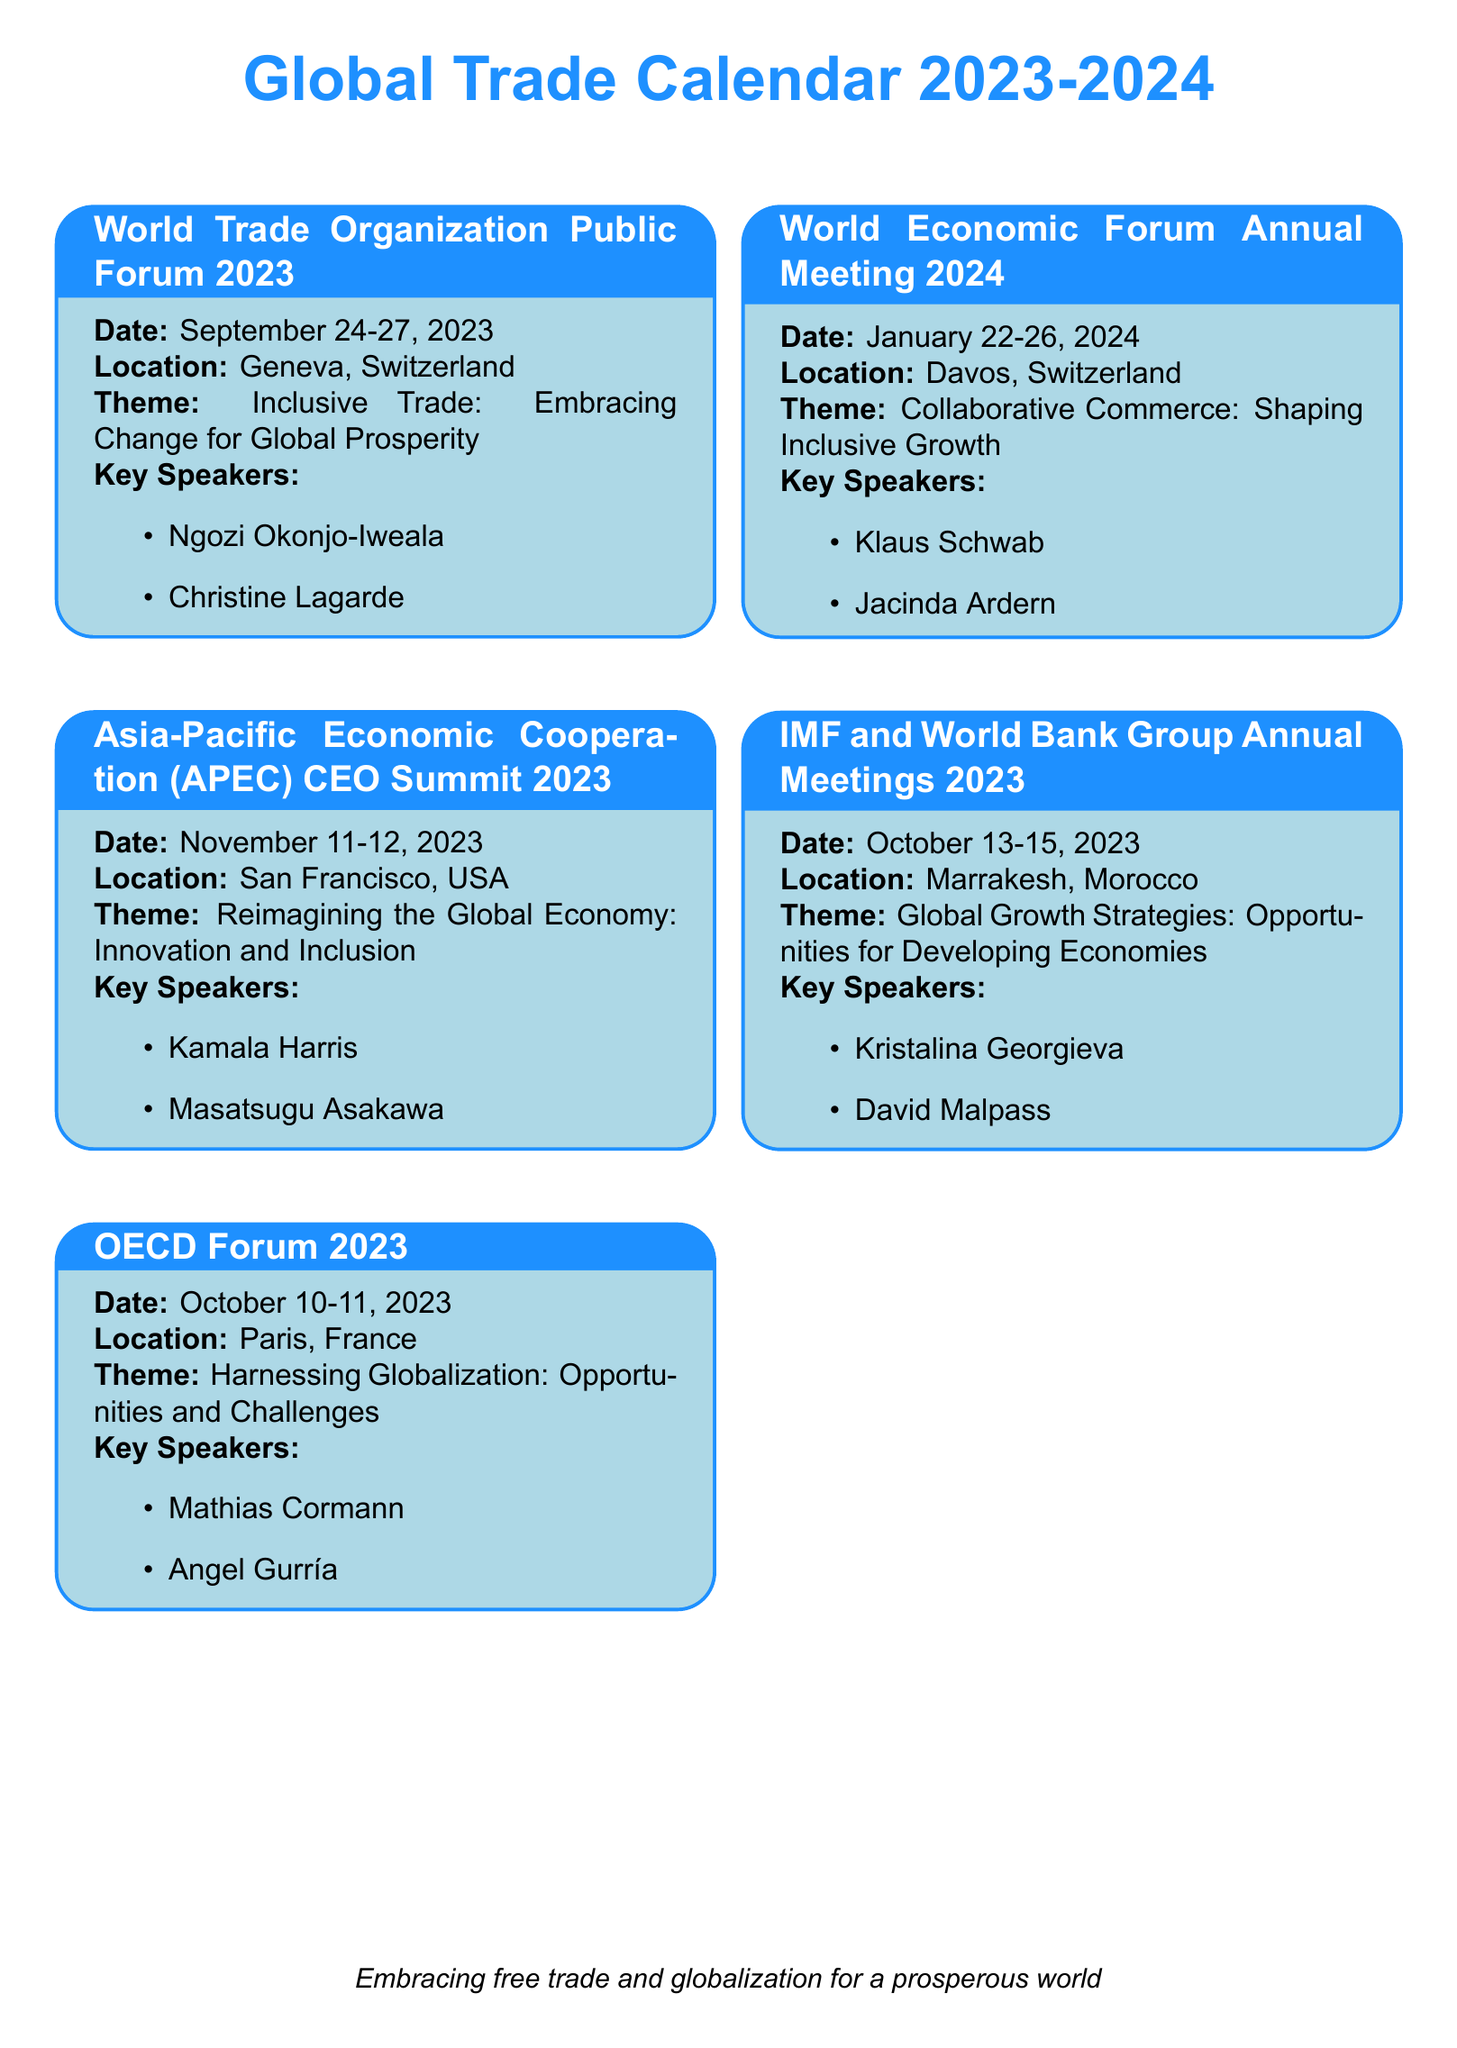What is the date of the World Trade Organization Public Forum 2023? The date is specified in the document as September 24-27, 2023.
Answer: September 24-27, 2023 Who is the keynote speaker at the Asia-Pacific Economic Cooperation CEO Summit 2023? The document lists Kamala Harris as one of the keynote speakers for this summit.
Answer: Kamala Harris What is the theme of the OECD Forum 2023? The theme is described in the document as Harnessing Globalization: Opportunities and Challenges.
Answer: Harnessing Globalization: Opportunities and Challenges Where is the World Economic Forum Annual Meeting 2024 being held? The document provides the location as Davos, Switzerland.
Answer: Davos, Switzerland Which two organizations will hold their annual meetings in October 2023? The document indicates that the IMF and World Bank Group are having their meetings in October 2023.
Answer: IMF and World Bank Group How many keynote speakers are listed for the World Trade Organization Public Forum 2023? According to the document, there are two keynote speakers listed for this event: Ngozi Okonjo-Iweala and Christine Lagarde.
Answer: Two What is the title of the theme for the World Economic Forum Annual Meeting 2024? The document outlines the theme as Collaborative Commerce: Shaping Inclusive Growth.
Answer: Collaborative Commerce: Shaping Inclusive Growth What is the total number of trade conferences listed in the document? The document lists a total of five trade conferences or summits.
Answer: Five 